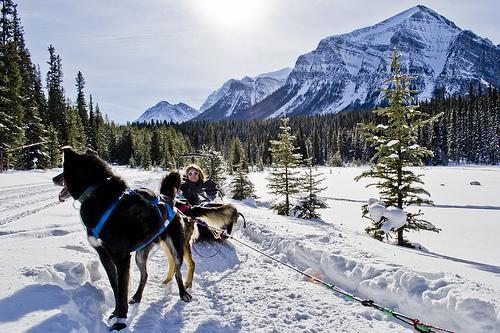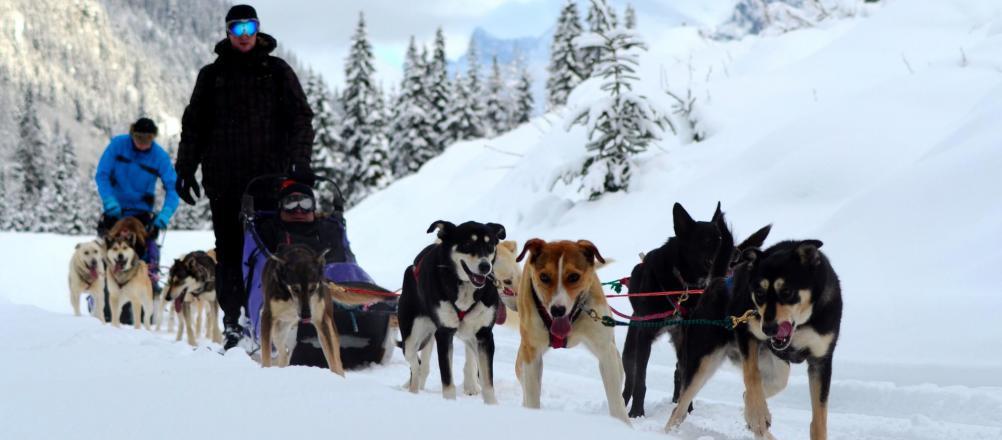The first image is the image on the left, the second image is the image on the right. For the images shown, is this caption "The righthand dog sled team heads straight toward the camera, and the lefthand team heads at a diagonal to the right." true? Answer yes or no. No. The first image is the image on the left, the second image is the image on the right. Analyze the images presented: Is the assertion "The left image contains no more than six sled dogs." valid? Answer yes or no. Yes. 